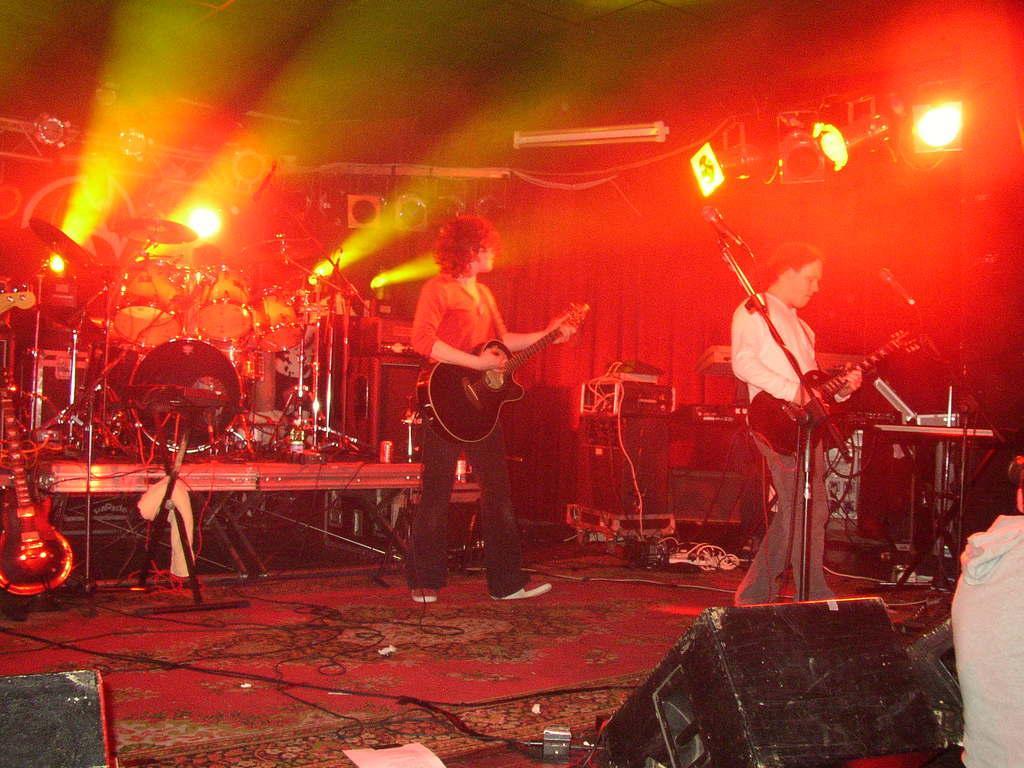Describe this image in one or two sentences. In the image there are two people standing and playing guitars, around them there are drums and other music equipment, in the background there are many lights. 